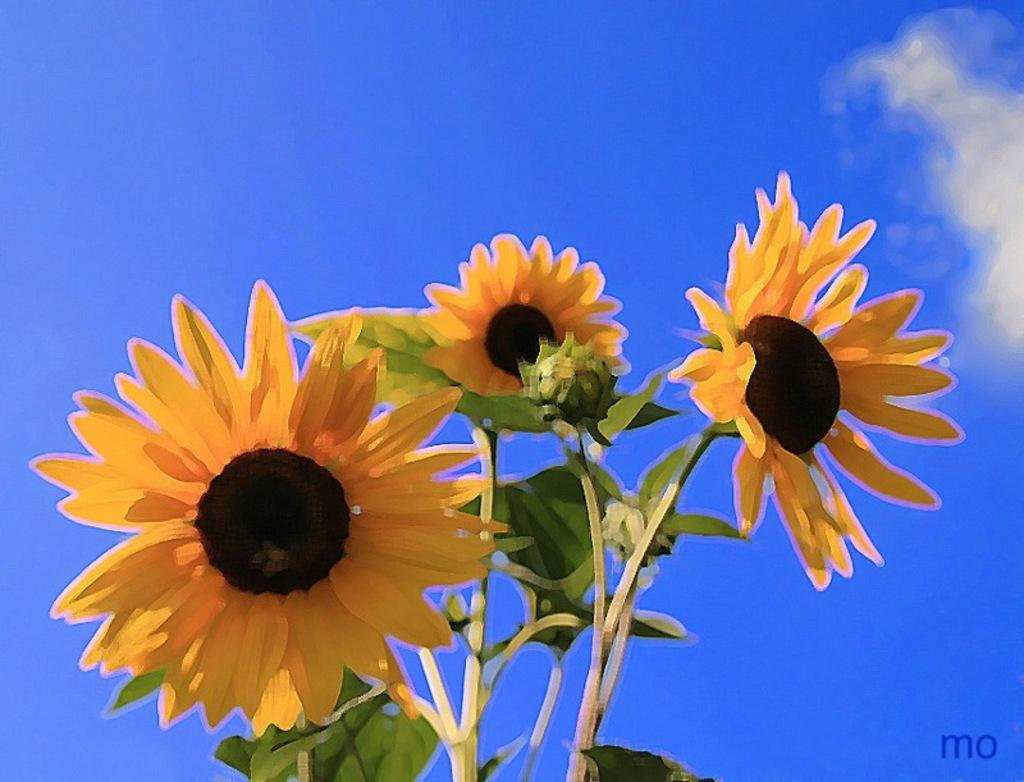What type of artwork is depicted in the image? The image appears to be a painting. What is the main subject of the painting? There are three sunflowers depicted in the painting. What part of the sunflower is visible in the painting? The sunflowers have stems in the painting. What can be seen in the background of the painting? There is a sky visible in the background of the painting. How are the sunflowers being transported in the image? There is no indication of transportation in the image; the sunflowers are depicted as part of a painting. Can you spot any spots on the sunflowers in the image? There are no visible spots on the sunflowers in the image. 